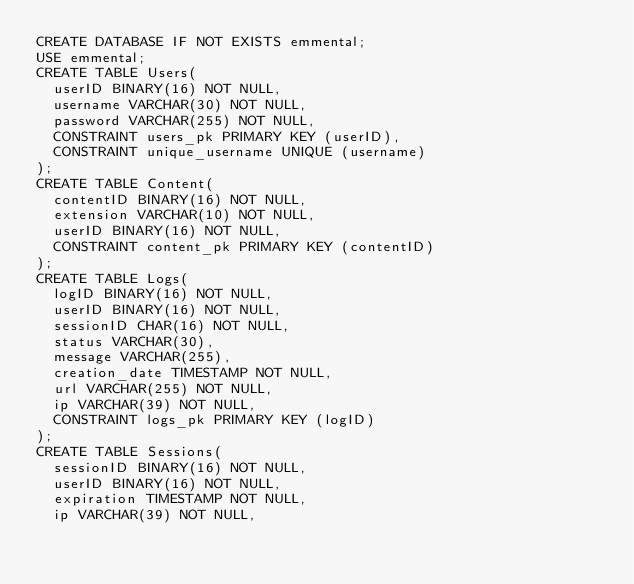<code> <loc_0><loc_0><loc_500><loc_500><_SQL_>CREATE DATABASE IF NOT EXISTS emmental;
USE emmental;
CREATE TABLE Users(
  userID BINARY(16) NOT NULL,
  username VARCHAR(30) NOT NULL,
  password VARCHAR(255) NOT NULL,
  CONSTRAINT users_pk PRIMARY KEY (userID),
  CONSTRAINT unique_username UNIQUE (username)
);
CREATE TABLE Content(
  contentID BINARY(16) NOT NULL,
  extension VARCHAR(10) NOT NULL,
  userID BINARY(16) NOT NULL,
  CONSTRAINT content_pk PRIMARY KEY (contentID)
);
CREATE TABLE Logs(
  logID BINARY(16) NOT NULL,
  userID BINARY(16) NOT NULL,
  sessionID CHAR(16) NOT NULL,
  status VARCHAR(30),
  message VARCHAR(255),
  creation_date TIMESTAMP NOT NULL,
  url VARCHAR(255) NOT NULL,
  ip VARCHAR(39) NOT NULL,
  CONSTRAINT logs_pk PRIMARY KEY (logID)
);
CREATE TABLE Sessions(
  sessionID BINARY(16) NOT NULL,
  userID BINARY(16) NOT NULL,
  expiration TIMESTAMP NOT NULL,
  ip VARCHAR(39) NOT NULL,</code> 